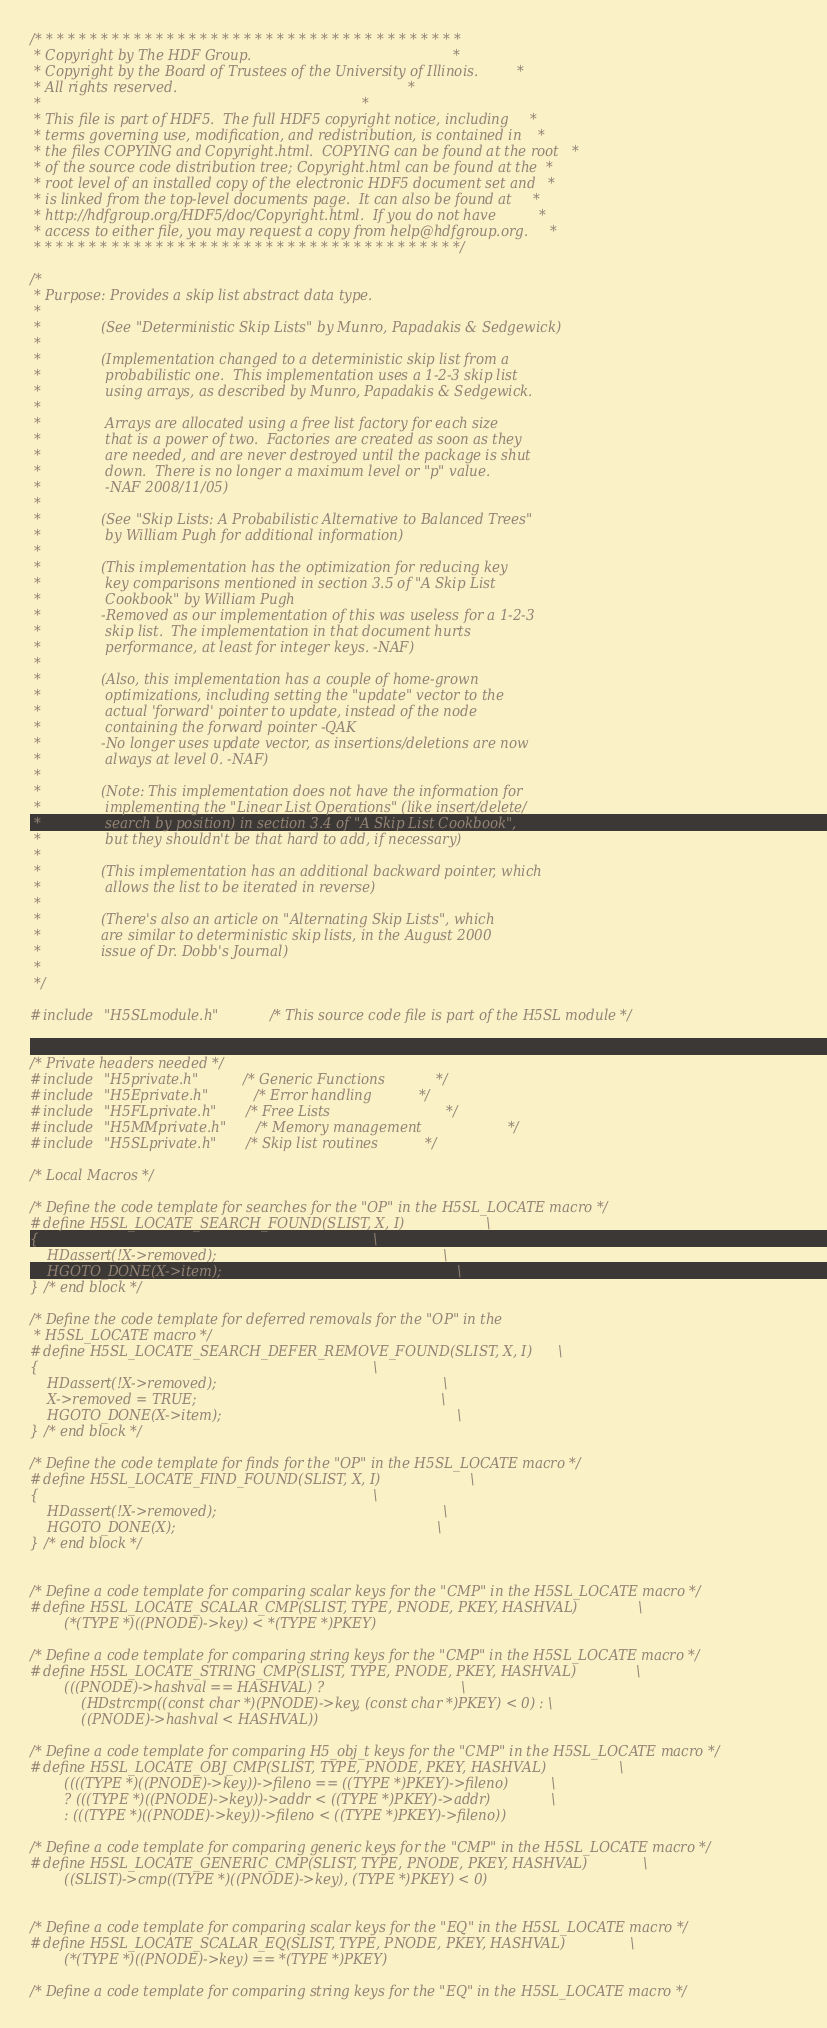Convert code to text. <code><loc_0><loc_0><loc_500><loc_500><_C_>/* * * * * * * * * * * * * * * * * * * * * * * * * * * * * * * * * * * * * * *
 * Copyright by The HDF Group.                                               *
 * Copyright by the Board of Trustees of the University of Illinois.         *
 * All rights reserved.                                                      *
 *                                                                           *
 * This file is part of HDF5.  The full HDF5 copyright notice, including     *
 * terms governing use, modification, and redistribution, is contained in    *
 * the files COPYING and Copyright.html.  COPYING can be found at the root   *
 * of the source code distribution tree; Copyright.html can be found at the  *
 * root level of an installed copy of the electronic HDF5 document set and   *
 * is linked from the top-level documents page.  It can also be found at     *
 * http://hdfgroup.org/HDF5/doc/Copyright.html.  If you do not have          *
 * access to either file, you may request a copy from help@hdfgroup.org.     *
 * * * * * * * * * * * * * * * * * * * * * * * * * * * * * * * * * * * * * * */

/*
 * Purpose:	Provides a skip list abstract data type.
 *
 *              (See "Deterministic Skip Lists" by Munro, Papadakis & Sedgewick)
 *
 *              (Implementation changed to a deterministic skip list from a
 *               probabilistic one.  This implementation uses a 1-2-3 skip list
 *               using arrays, as described by Munro, Papadakis & Sedgewick.
 *
 *               Arrays are allocated using a free list factory for each size
 *               that is a power of two.  Factories are created as soon as they
 *               are needed, and are never destroyed until the package is shut
 *               down.  There is no longer a maximum level or "p" value.
 *               -NAF 2008/11/05)
 *
 *              (See "Skip Lists: A Probabilistic Alternative to Balanced Trees"
 *               by William Pugh for additional information)
 *
 *              (This implementation has the optimization for reducing key
 *               key comparisons mentioned in section 3.5 of "A Skip List
 *               Cookbook" by William Pugh
 *              -Removed as our implementation of this was useless for a 1-2-3
 *               skip list.  The implementation in that document hurts
 *               performance, at least for integer keys. -NAF)
 *
 *              (Also, this implementation has a couple of home-grown
 *               optimizations, including setting the "update" vector to the
 *               actual 'forward' pointer to update, instead of the node
 *               containing the forward pointer -QAK
 *              -No longer uses update vector, as insertions/deletions are now
 *               always at level 0. -NAF)
 *
 *              (Note: This implementation does not have the information for
 *               implementing the "Linear List Operations" (like insert/delete/
 *               search by position) in section 3.4 of "A Skip List Cookbook",
 *               but they shouldn't be that hard to add, if necessary)
 *
 *              (This implementation has an additional backward pointer, which
 *               allows the list to be iterated in reverse)
 *
 *              (There's also an article on "Alternating Skip Lists", which
 *              are similar to deterministic skip lists, in the August 2000
 *              issue of Dr. Dobb's Journal)
 *
 */

#include "H5SLmodule.h"         /* This source code file is part of the H5SL module */


/* Private headers needed */
#include "H5private.h"		/* Generic Functions			*/
#include "H5Eprivate.h"		/* Error handling		  	*/
#include "H5FLprivate.h"	/* Free Lists                           */
#include "H5MMprivate.h"	/* Memory management                    */
#include "H5SLprivate.h"	/* Skip list routines			*/

/* Local Macros */

/* Define the code template for searches for the "OP" in the H5SL_LOCATE macro */
#define H5SL_LOCATE_SEARCH_FOUND(SLIST, X, I)                   \
{                                                                              \
    HDassert(!X->removed);                                                     \
    HGOTO_DONE(X->item);                                                       \
} /* end block */

/* Define the code template for deferred removals for the "OP" in the
 * H5SL_LOCATE macro */
#define H5SL_LOCATE_SEARCH_DEFER_REMOVE_FOUND(SLIST, X, I)      \
{                                                                              \
    HDassert(!X->removed);                                                     \
    X->removed = TRUE;                                                         \
    HGOTO_DONE(X->item);                                                       \
} /* end block */

/* Define the code template for finds for the "OP" in the H5SL_LOCATE macro */
#define H5SL_LOCATE_FIND_FOUND(SLIST, X, I)                     \
{                                                                              \
    HDassert(!X->removed);                                                     \
    HGOTO_DONE(X);                                                             \
} /* end block */


/* Define a code template for comparing scalar keys for the "CMP" in the H5SL_LOCATE macro */
#define H5SL_LOCATE_SCALAR_CMP(SLIST, TYPE, PNODE, PKEY, HASHVAL)              \
        (*(TYPE *)((PNODE)->key) < *(TYPE *)PKEY)

/* Define a code template for comparing string keys for the "CMP" in the H5SL_LOCATE macro */
#define H5SL_LOCATE_STRING_CMP(SLIST, TYPE, PNODE, PKEY, HASHVAL)              \
        (((PNODE)->hashval == HASHVAL) ?                                \
            (HDstrcmp((const char *)(PNODE)->key, (const char *)PKEY) < 0) : \
            ((PNODE)->hashval < HASHVAL))

/* Define a code template for comparing H5_obj_t keys for the "CMP" in the H5SL_LOCATE macro */
#define H5SL_LOCATE_OBJ_CMP(SLIST, TYPE, PNODE, PKEY, HASHVAL)                 \
        ((((TYPE *)((PNODE)->key))->fileno == ((TYPE *)PKEY)->fileno)          \
        ? (((TYPE *)((PNODE)->key))->addr < ((TYPE *)PKEY)->addr)              \
        : (((TYPE *)((PNODE)->key))->fileno < ((TYPE *)PKEY)->fileno))

/* Define a code template for comparing generic keys for the "CMP" in the H5SL_LOCATE macro */
#define H5SL_LOCATE_GENERIC_CMP(SLIST, TYPE, PNODE, PKEY, HASHVAL)             \
        ((SLIST)->cmp((TYPE *)((PNODE)->key), (TYPE *)PKEY) < 0)


/* Define a code template for comparing scalar keys for the "EQ" in the H5SL_LOCATE macro */
#define H5SL_LOCATE_SCALAR_EQ(SLIST, TYPE, PNODE, PKEY, HASHVAL)               \
        (*(TYPE *)((PNODE)->key) == *(TYPE *)PKEY)

/* Define a code template for comparing string keys for the "EQ" in the H5SL_LOCATE macro */</code> 